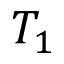Convert formula to latex. <formula><loc_0><loc_0><loc_500><loc_500>T _ { 1 }</formula> 